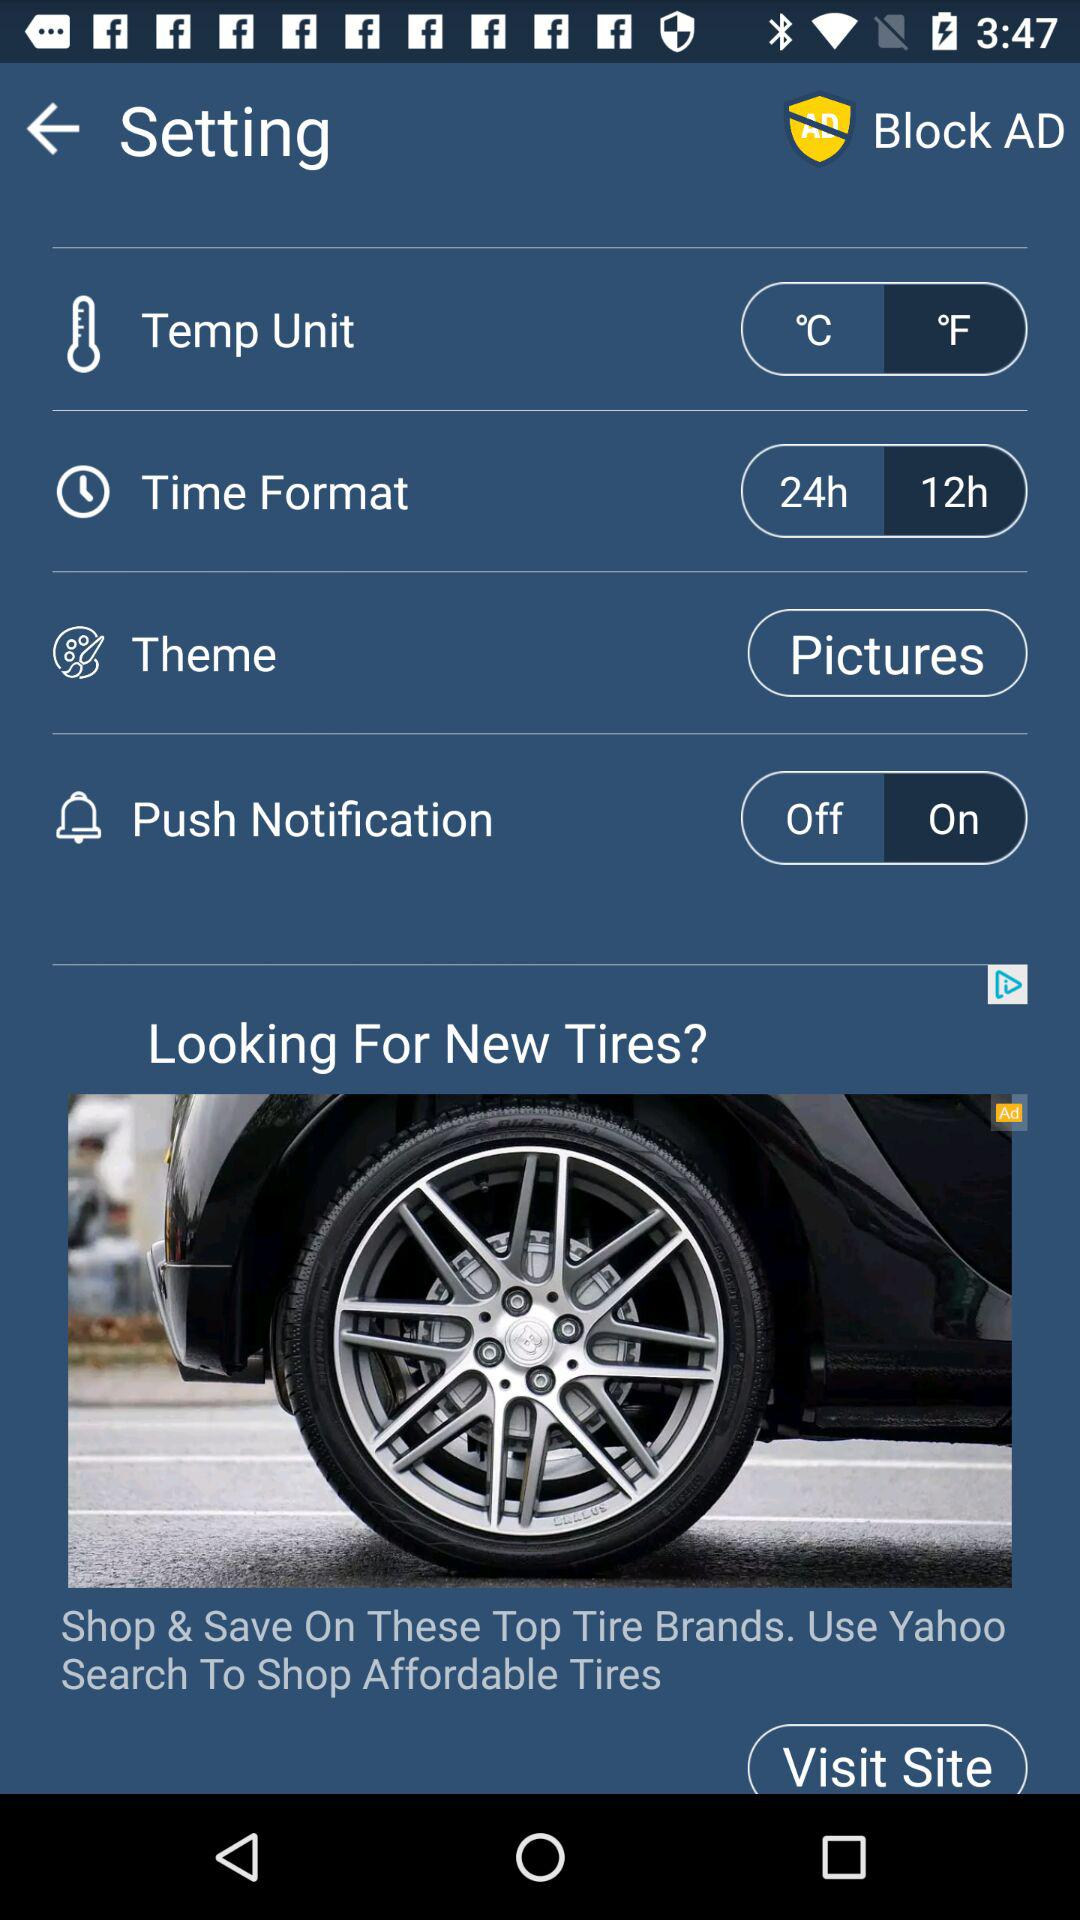What is the status of "Push Notification"? The status is "on". 